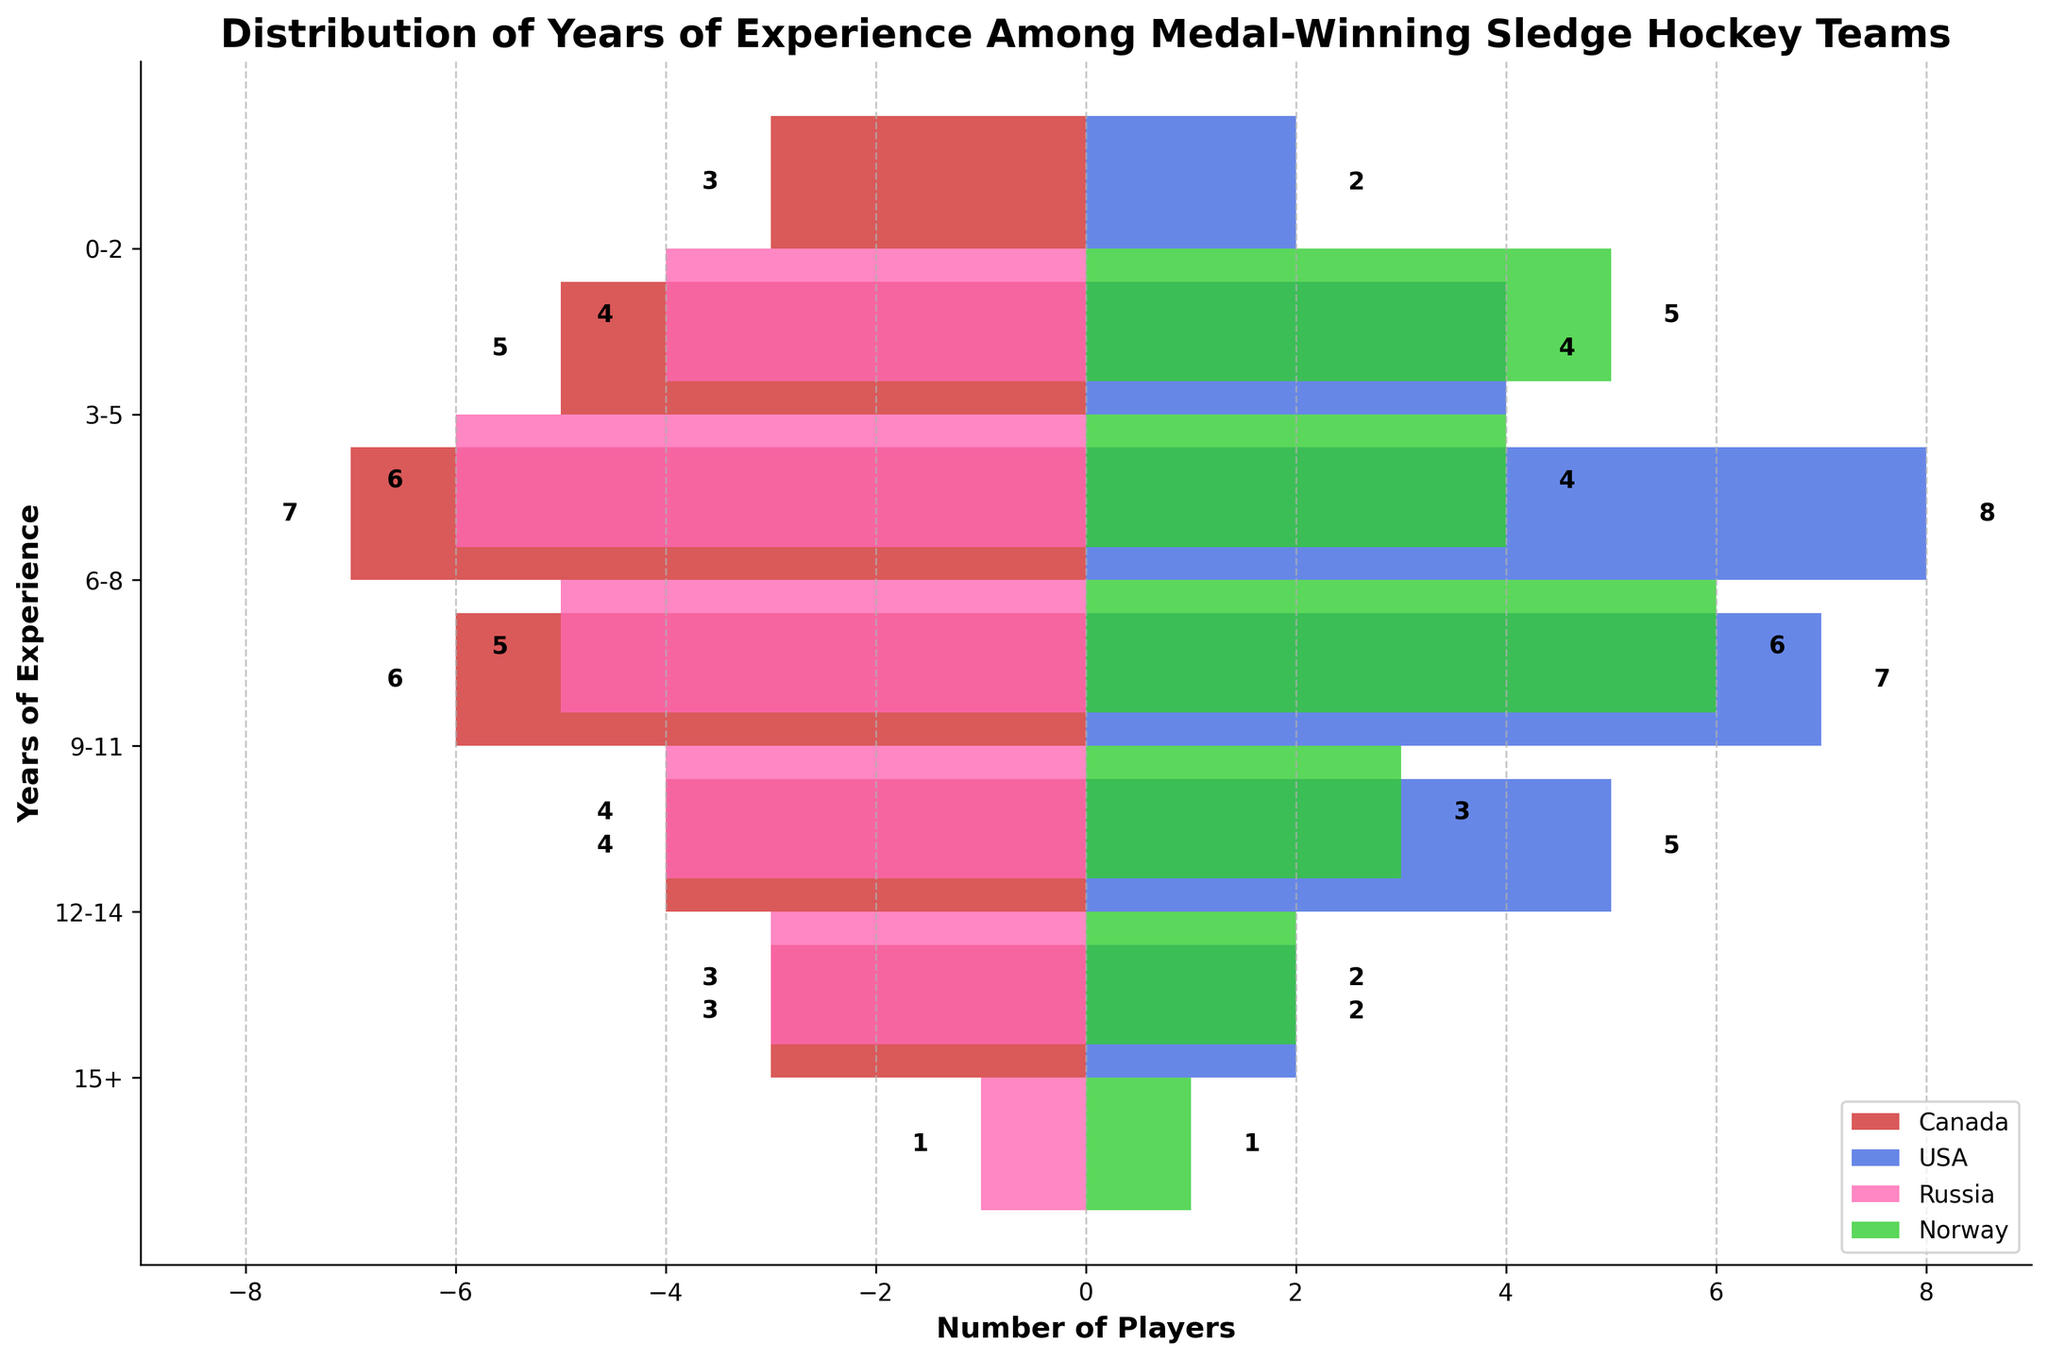What is the title of the figure? The title is located at the top of the figure and typically summarises the content.
Answer: Distribution of Years of Experience Among Medal-Winning Sledge Hockey Teams Which country has the most players with 6-8 years of experience? By examining the bars corresponding to the '6-8' years of experience category, the highest bar indicates the country with the most players. USA has the highest bar at 8.
Answer: USA What is the range of years of experience categories shown in the figure? The y-axis lists the categories of years of experience from the bottom to the top. The range includes '0-2', '3-5', '6-8', '9-11', '12-14', and '15+'.
Answer: 0-2 to 15+ Which country has the least players in the '15+' years of experience category? The smallest bars in the '15+' category indicate the countries with the least players. Both Russia and Norway have the smallest bar at 1 player each.
Answer: Russia and Norway Is the number of players with 0-2 years of experience higher for Norway or Canada? Compare the bars for Norway and Canada in the '0-2' years of experience category. Norway has a higher bar at 5 players compared to Canada's 3.
Answer: Norway How many more players in the '9-11' years category does USA have compared to Russia? Subtract the number of Russian players from the number of USA players in the '9-11' years of experience category. USA has 7, and Russia has 4. So, 7 - 4 = 3.
Answer: 3 What is the total number of players across all experience categories for Canada? Add up all the values for Canada: 3 (0-2) + 5 (3-5) + 7 (6-8) + 6 (9-11) + 4 (12-14) + 3 (15+). This sums up to 28 players.
Answer: 28 Which country has a more balanced distribution across the experience categories, based on the figure? By comparing the bars of each country across all categories, assess which country has similar-sized bars, indicating balanced distribution. Canada has relatively balanced numbers across the categories.
Answer: Canada Are there more players with 6-8 years of experience or with 9-11 years of experience in total? Add the number of players across all countries for the '6-8' category and compare it to the sum for the '9-11' category. 6-8: 7+8+5+6 = 26; 9-11: 6+7+4+3 = 20.
Answer: 6-8 Considering all categories, which team has the highest cumulative number of players with more than 5 years of experience? Sum the players in the categories '6-8', '9-11', '12-14', and '15+' for each team. Canada: 7+6+4+3=20; USA: 8+7+5+2=22; Russia: 5+4+3+1=13; Norway: 6+3+2+1=12. USA has the highest cumulative number.
Answer: USA 